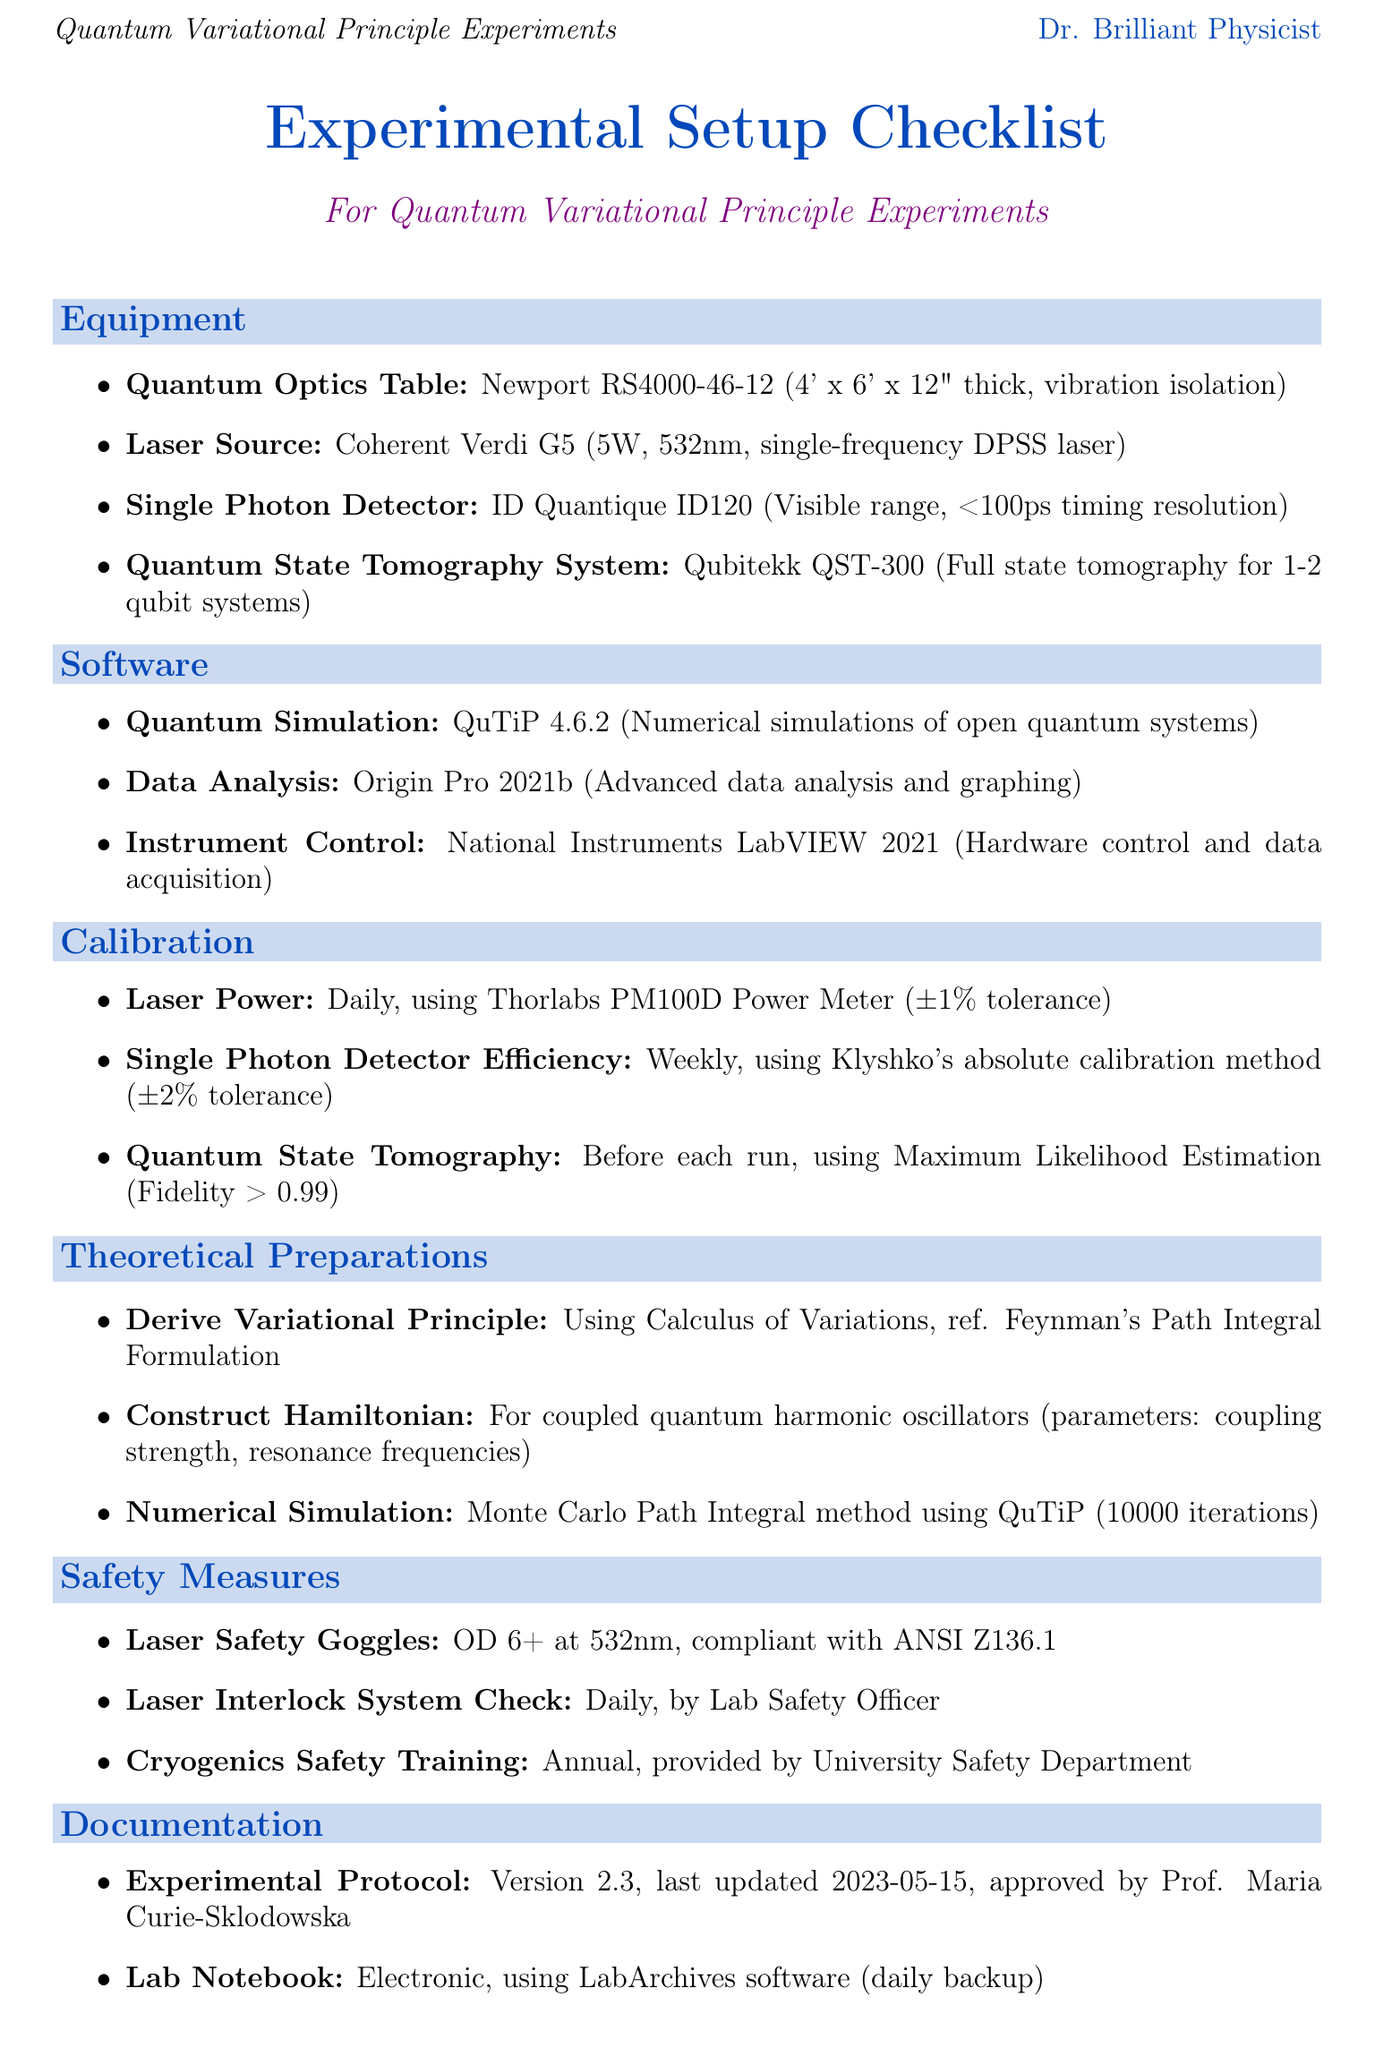What is the model of the Laser Source? The laser source is identified as Coherent Verdi G5 in the document.
Answer: Coherent Verdi G5 What is the calibration frequency for the Single Photon Detector Efficiency? The document specifies that the efficiency should be calibrated on a weekly basis.
Answer: Weekly What is the purpose of the Quantum Simulation Software? The document states it is for numerical simulations of open quantum systems.
Answer: Numerical simulations of open quantum systems What is the tolerance for Laser Power Calibration? According to the document, the tolerance for laser power calibration is ±1%.
Answer: ±1% Who approved the Experimental Protocol? The document indicates that Prof. Maria Curie-Sklodowska approved the experimental protocol.
Answer: Prof. Maria Curie-Sklodowska How many iterations are mentioned for the Numerical Simulation? The document specifies the number of iterations for the numerical simulation as 10000.
Answer: 10000 What safety standard do the Laser Safety Goggles comply with? The document states that they comply with ANSI Z136.1.
Answer: ANSI Z136.1 What method is used for Quantum State Tomography Calibration? The document mentions Maximum Likelihood Estimation as the calibration method.
Answer: Maximum Likelihood Estimation 